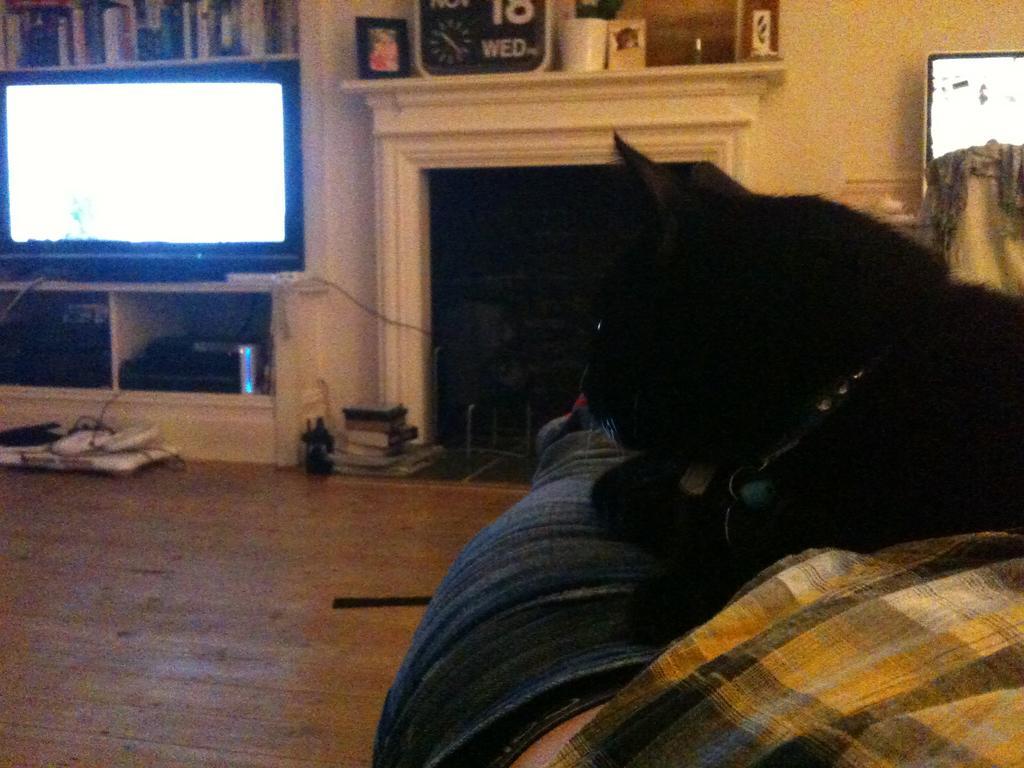How would you summarize this image in a sentence or two? In this image I can see a black color of animal sitting over here. In the background I can see television, fireplace, photo frame and a clock. 